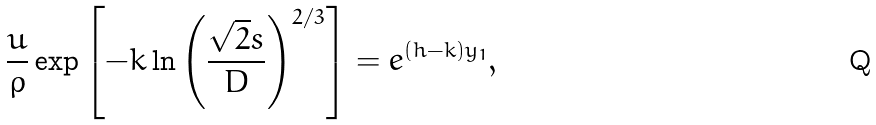<formula> <loc_0><loc_0><loc_500><loc_500>\frac { u } { \rho } \exp \left [ - k \ln \left ( \frac { \sqrt { 2 } s } { D } \right ) ^ { 2 / 3 } \right ] = e ^ { ( h - k ) y _ { 1 } } ,</formula> 